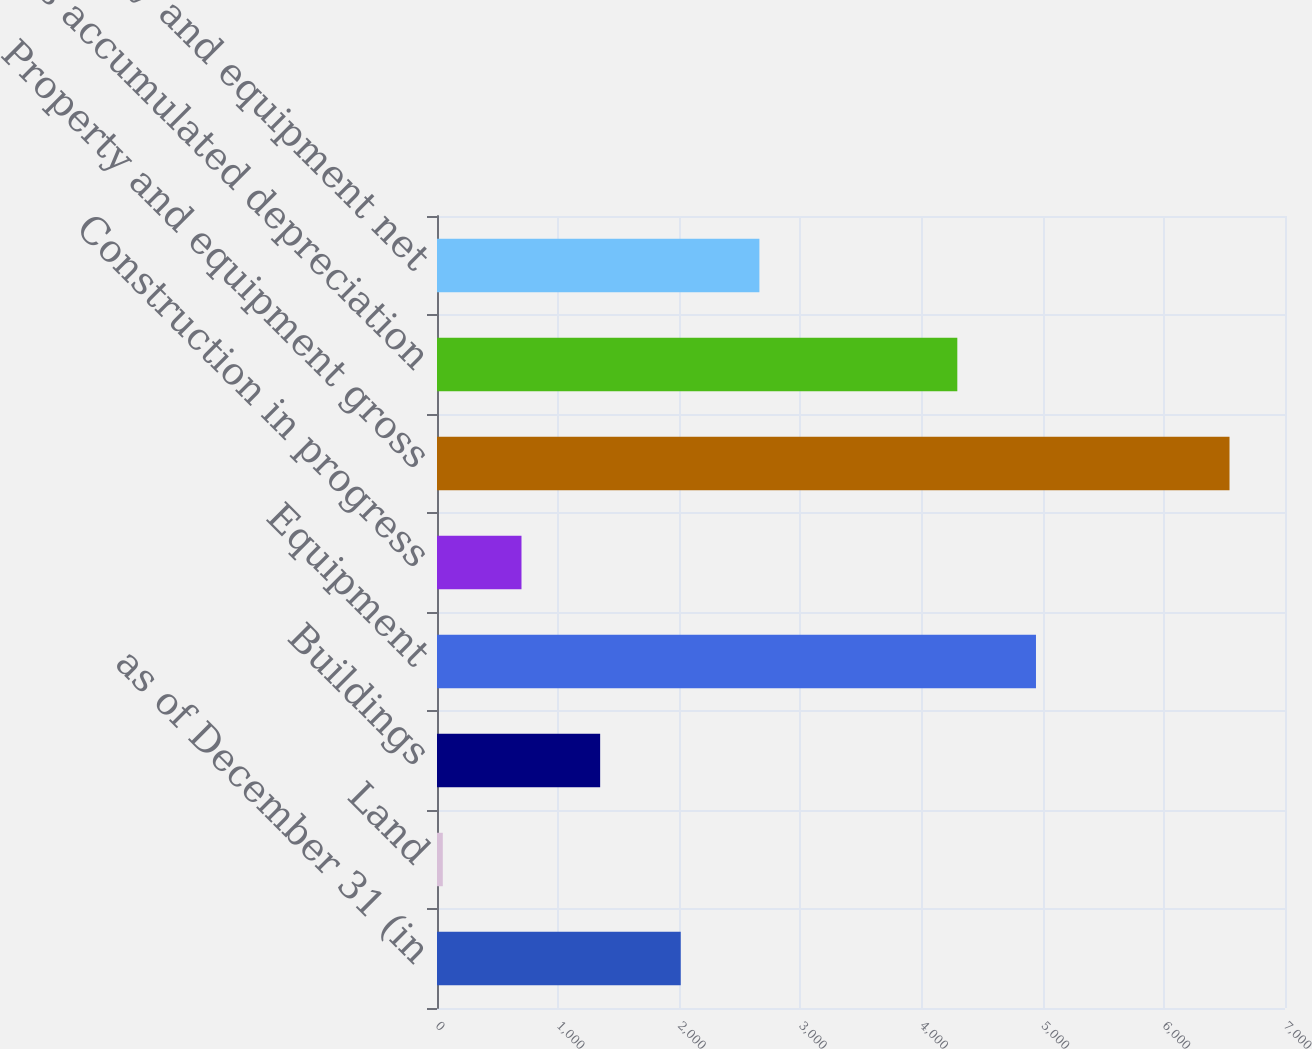Convert chart to OTSL. <chart><loc_0><loc_0><loc_500><loc_500><bar_chart><fcel>as of December 31 (in<fcel>Land<fcel>Buildings<fcel>Equipment<fcel>Construction in progress<fcel>Property and equipment gross<fcel>Less accumulated depreciation<fcel>Property and equipment net<nl><fcel>2012<fcel>48<fcel>1346.8<fcel>4944.4<fcel>697.4<fcel>6542<fcel>4295<fcel>2661.4<nl></chart> 